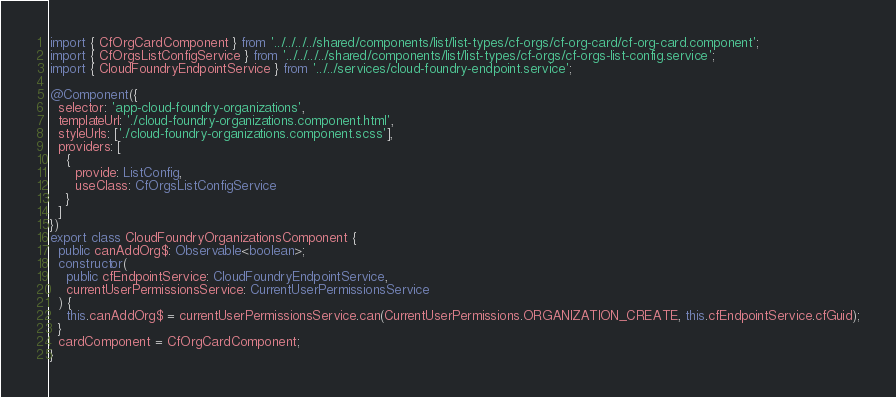Convert code to text. <code><loc_0><loc_0><loc_500><loc_500><_TypeScript_>import { CfOrgCardComponent } from '../../../../shared/components/list/list-types/cf-orgs/cf-org-card/cf-org-card.component';
import { CfOrgsListConfigService } from '../../../../shared/components/list/list-types/cf-orgs/cf-orgs-list-config.service';
import { CloudFoundryEndpointService } from '../../services/cloud-foundry-endpoint.service';

@Component({
  selector: 'app-cloud-foundry-organizations',
  templateUrl: './cloud-foundry-organizations.component.html',
  styleUrls: ['./cloud-foundry-organizations.component.scss'],
  providers: [
    {
      provide: ListConfig,
      useClass: CfOrgsListConfigService
    }
  ]
})
export class CloudFoundryOrganizationsComponent {
  public canAddOrg$: Observable<boolean>;
  constructor(
    public cfEndpointService: CloudFoundryEndpointService,
    currentUserPermissionsService: CurrentUserPermissionsService
  ) {
    this.canAddOrg$ = currentUserPermissionsService.can(CurrentUserPermissions.ORGANIZATION_CREATE, this.cfEndpointService.cfGuid);
  }
  cardComponent = CfOrgCardComponent;
}
</code> 